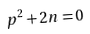<formula> <loc_0><loc_0><loc_500><loc_500>p ^ { 2 } + 2 n = 0</formula> 